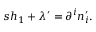Convert formula to latex. <formula><loc_0><loc_0><loc_500><loc_500>s h _ { 1 } + \lambda ^ { \prime } = \partial ^ { i } n _ { i } ^ { \prime } .</formula> 